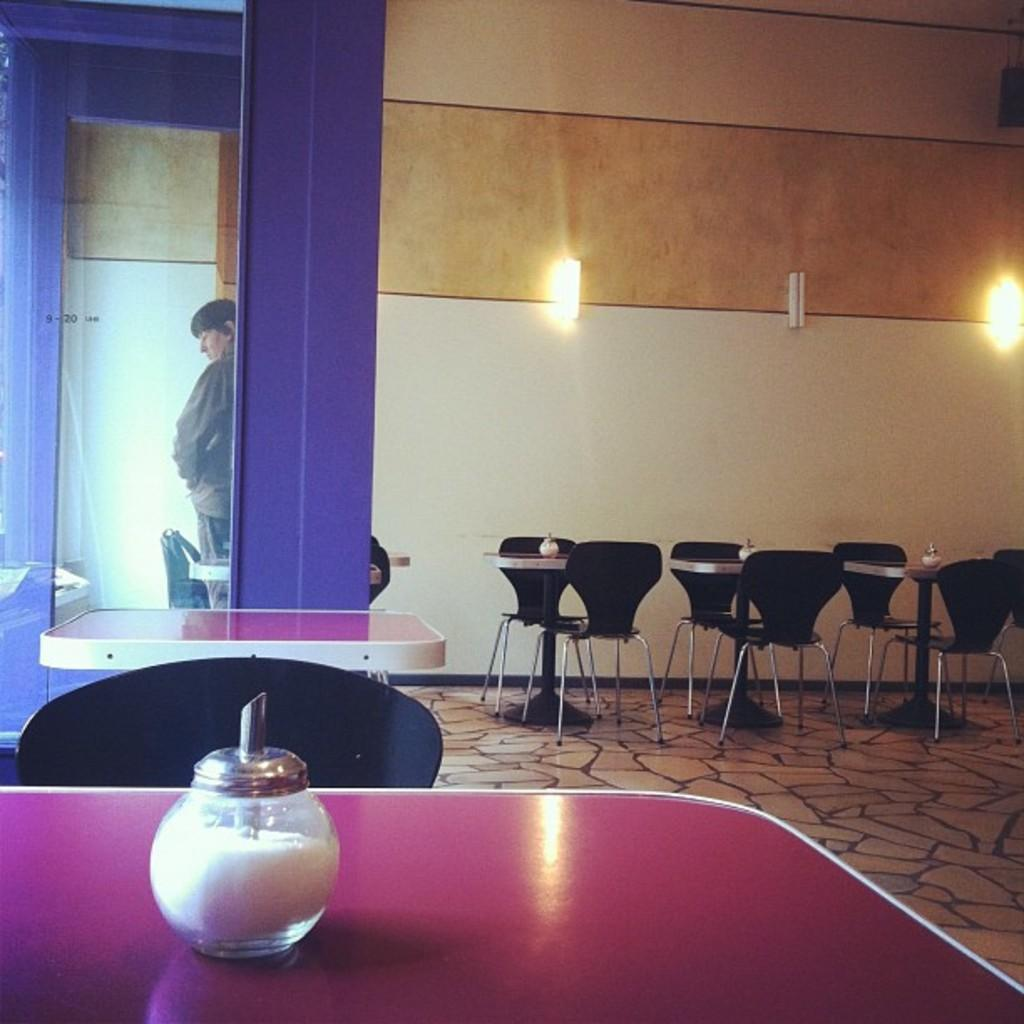What type of furniture can be seen in the image? There are tables and chairs in the image. What material is visible in the image? Glass is visible in the image. Is there a person present in the image? Yes, there is a person in the image. What objects are on the tables in the image? Bottles are present on the tables. What can be seen on the floor in the image? The floor is visible in the image. What is visible in the background of the image? There are lights and a wall in the background of the image. Can you tell me how many clams are sitting on the chairs in the image? There are no clams present in the image; it features tables, chairs, glass, a person, bottles, the floor, lights, and a wall. What type of bird is perched on the wall in the image? There is no bird, specifically a wren, present on the wall in the image. 